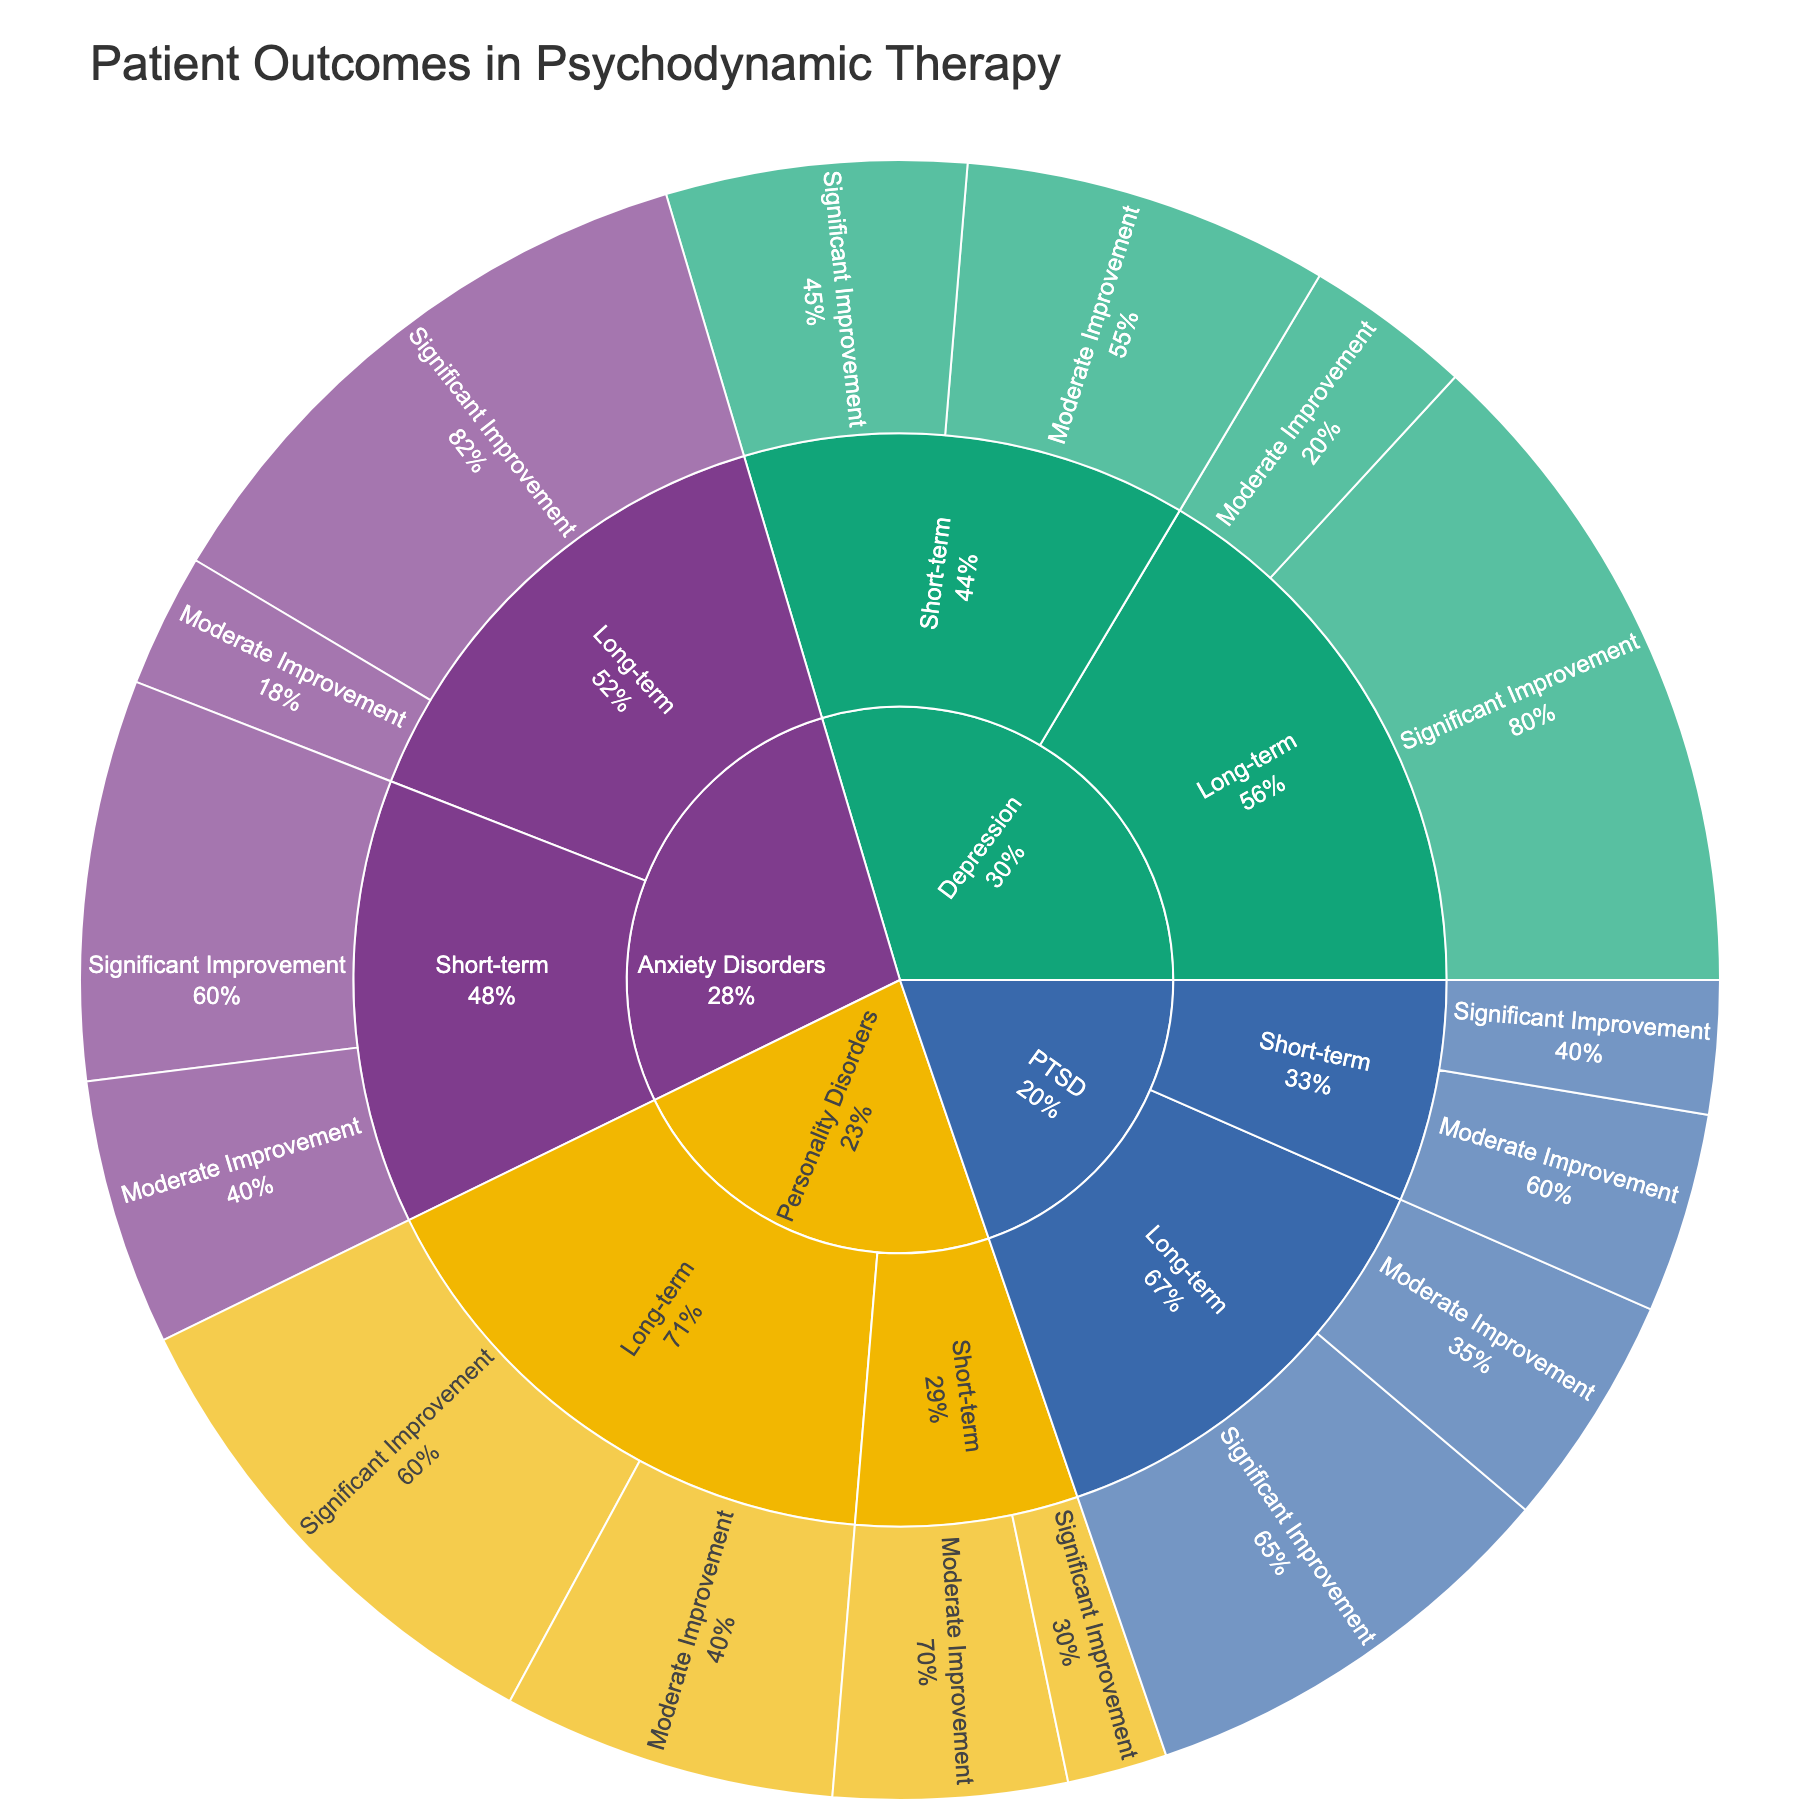What is the title of the figure? The title of the figure is located at the top and clearly states the purpose of the visualization.
Answer: Patient Outcomes in Psychodynamic Therapy Which disorder shows the highest number of patients with significant improvement in long-term treatment? By visually inspecting the segment sizes and labels under the long-term treatment category, we can see that 'Depression' has the largest segment for 'Significant Improvement'.
Answer: Depression For Anxiety Disorders, how many patients experienced moderate improvement regardless of the treatment duration? Add up the number of patients experiencing moderate improvement in both short-term and long-term treatments. 80 (short-term) + 40 (long-term) = 120 patients.
Answer: 120 Which treatment duration shows a higher proportion of significant improvement for Personality Disorders? Compare the proportion (or size) of segments for 'Significant Improvement' under both short-term and long-term treatments for 'Personality Disorders'. Long-term is larger.
Answer: Long-term How does the number of patients with moderate improvement in long-term treatment for PTSD compare to that of short-term treatment? Compare the segment sizes labeled 'Moderate Improvement' within the PTSD category for both treatment durations. Long-term (70) is slightly higher than short-term (60).
Answer: Long-term is higher What percentage of patients with short-term treatment for Depression saw significant improvement? Calculate the ratio of patients with significant improvement to the total number of short-term patients and then convert to percentage: (90 / (90+110)) * 100 = 45%.
Answer: 45% Which disorder has the least number of patients showing significant improvement in short-term treatment? Compare the 'Significant Improvement' segments under short-term treatment across all disorders, noting the smallest segment. 'Personality Disorders' has the smallest number.
Answer: Personality Disorders If we sum the patients who saw significant improvement in both treatment durations for Anxiety Disorders, what is the total number? Add the patients with significant improvement in short-term and long-term: 120 (short-term) + 180 (long-term) = 300 patients.
Answer: 300 What is the proportion of patients with long-term treatment who showed moderate improvement in PTSD relative to those who showed significant improvement? Calculate the ratio of patients with moderate improvement to those with significant improvement for PTSD under long-term treatment: 70 / 130 = 0.538 or about 54%.
Answer: Approximately 54% How many patients in total are represented in the figure? Sum up the patients from all categories and subcategories: 120+80+180+40+90+110+200+50+30+70+150+100+40+60+130+70 = 1620 patients.
Answer: 1620 